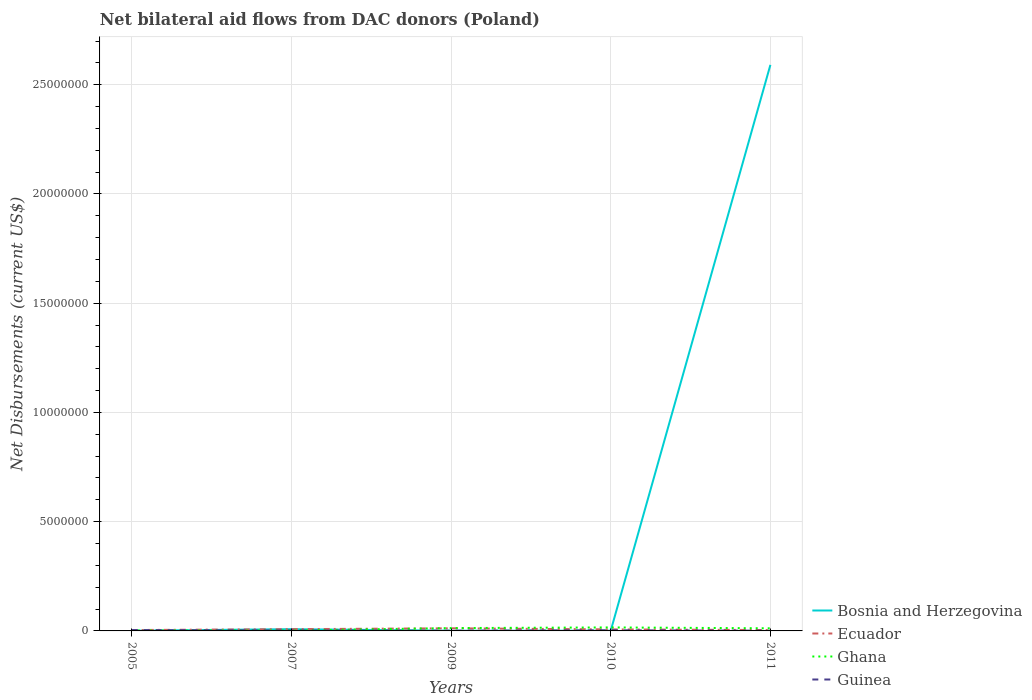Is the number of lines equal to the number of legend labels?
Your response must be concise. Yes. Across all years, what is the maximum net bilateral aid flows in Ecuador?
Offer a very short reply. 4.00e+04. What is the total net bilateral aid flows in Bosnia and Herzegovina in the graph?
Ensure brevity in your answer.  -2.59e+07. Does the graph contain any zero values?
Your answer should be compact. No. Does the graph contain grids?
Your answer should be compact. Yes. How are the legend labels stacked?
Ensure brevity in your answer.  Vertical. What is the title of the graph?
Your response must be concise. Net bilateral aid flows from DAC donors (Poland). What is the label or title of the Y-axis?
Your answer should be compact. Net Disbursements (current US$). What is the Net Disbursements (current US$) in Ecuador in 2005?
Your answer should be very brief. 4.00e+04. What is the Net Disbursements (current US$) of Ghana in 2009?
Offer a terse response. 1.30e+05. What is the Net Disbursements (current US$) of Guinea in 2009?
Provide a succinct answer. 10000. What is the Net Disbursements (current US$) of Bosnia and Herzegovina in 2010?
Provide a short and direct response. 10000. What is the Net Disbursements (current US$) of Ecuador in 2010?
Provide a short and direct response. 7.00e+04. What is the Net Disbursements (current US$) in Guinea in 2010?
Ensure brevity in your answer.  3.00e+04. What is the Net Disbursements (current US$) of Bosnia and Herzegovina in 2011?
Provide a short and direct response. 2.59e+07. What is the Net Disbursements (current US$) of Ecuador in 2011?
Your response must be concise. 4.00e+04. What is the Net Disbursements (current US$) in Ghana in 2011?
Make the answer very short. 1.20e+05. What is the Net Disbursements (current US$) of Guinea in 2011?
Offer a very short reply. 10000. Across all years, what is the maximum Net Disbursements (current US$) in Bosnia and Herzegovina?
Your response must be concise. 2.59e+07. Across all years, what is the minimum Net Disbursements (current US$) of Ghana?
Make the answer very short. 2.00e+04. What is the total Net Disbursements (current US$) of Bosnia and Herzegovina in the graph?
Your answer should be compact. 2.60e+07. What is the total Net Disbursements (current US$) of Ecuador in the graph?
Offer a very short reply. 3.50e+05. What is the difference between the Net Disbursements (current US$) of Bosnia and Herzegovina in 2005 and that in 2007?
Offer a very short reply. -7.00e+04. What is the difference between the Net Disbursements (current US$) of Ghana in 2005 and that in 2007?
Your response must be concise. 0. What is the difference between the Net Disbursements (current US$) of Ghana in 2005 and that in 2009?
Ensure brevity in your answer.  -1.10e+05. What is the difference between the Net Disbursements (current US$) in Ghana in 2005 and that in 2010?
Provide a succinct answer. -1.40e+05. What is the difference between the Net Disbursements (current US$) in Bosnia and Herzegovina in 2005 and that in 2011?
Provide a succinct answer. -2.59e+07. What is the difference between the Net Disbursements (current US$) of Ecuador in 2005 and that in 2011?
Your answer should be compact. 0. What is the difference between the Net Disbursements (current US$) in Ghana in 2005 and that in 2011?
Offer a terse response. -1.00e+05. What is the difference between the Net Disbursements (current US$) of Guinea in 2005 and that in 2011?
Your response must be concise. 3.00e+04. What is the difference between the Net Disbursements (current US$) of Bosnia and Herzegovina in 2007 and that in 2009?
Your answer should be very brief. 7.00e+04. What is the difference between the Net Disbursements (current US$) in Ghana in 2007 and that in 2009?
Give a very brief answer. -1.10e+05. What is the difference between the Net Disbursements (current US$) in Bosnia and Herzegovina in 2007 and that in 2010?
Offer a terse response. 7.00e+04. What is the difference between the Net Disbursements (current US$) of Ecuador in 2007 and that in 2010?
Make the answer very short. 10000. What is the difference between the Net Disbursements (current US$) of Ghana in 2007 and that in 2010?
Your response must be concise. -1.40e+05. What is the difference between the Net Disbursements (current US$) of Bosnia and Herzegovina in 2007 and that in 2011?
Give a very brief answer. -2.58e+07. What is the difference between the Net Disbursements (current US$) in Ghana in 2007 and that in 2011?
Keep it short and to the point. -1.00e+05. What is the difference between the Net Disbursements (current US$) of Bosnia and Herzegovina in 2009 and that in 2010?
Your answer should be compact. 0. What is the difference between the Net Disbursements (current US$) in Bosnia and Herzegovina in 2009 and that in 2011?
Offer a very short reply. -2.59e+07. What is the difference between the Net Disbursements (current US$) in Guinea in 2009 and that in 2011?
Your response must be concise. 0. What is the difference between the Net Disbursements (current US$) of Bosnia and Herzegovina in 2010 and that in 2011?
Give a very brief answer. -2.59e+07. What is the difference between the Net Disbursements (current US$) of Ecuador in 2010 and that in 2011?
Offer a terse response. 3.00e+04. What is the difference between the Net Disbursements (current US$) in Ghana in 2010 and that in 2011?
Your answer should be compact. 4.00e+04. What is the difference between the Net Disbursements (current US$) of Bosnia and Herzegovina in 2005 and the Net Disbursements (current US$) of Ecuador in 2007?
Give a very brief answer. -7.00e+04. What is the difference between the Net Disbursements (current US$) of Bosnia and Herzegovina in 2005 and the Net Disbursements (current US$) of Guinea in 2007?
Keep it short and to the point. -10000. What is the difference between the Net Disbursements (current US$) of Ecuador in 2005 and the Net Disbursements (current US$) of Ghana in 2007?
Give a very brief answer. 2.00e+04. What is the difference between the Net Disbursements (current US$) in Bosnia and Herzegovina in 2005 and the Net Disbursements (current US$) in Ecuador in 2009?
Provide a short and direct response. -1.10e+05. What is the difference between the Net Disbursements (current US$) of Ecuador in 2005 and the Net Disbursements (current US$) of Ghana in 2009?
Ensure brevity in your answer.  -9.00e+04. What is the difference between the Net Disbursements (current US$) of Ecuador in 2005 and the Net Disbursements (current US$) of Guinea in 2009?
Make the answer very short. 3.00e+04. What is the difference between the Net Disbursements (current US$) in Ghana in 2005 and the Net Disbursements (current US$) in Guinea in 2009?
Ensure brevity in your answer.  10000. What is the difference between the Net Disbursements (current US$) in Ecuador in 2005 and the Net Disbursements (current US$) in Guinea in 2010?
Give a very brief answer. 10000. What is the difference between the Net Disbursements (current US$) in Ghana in 2005 and the Net Disbursements (current US$) in Guinea in 2010?
Offer a very short reply. -10000. What is the difference between the Net Disbursements (current US$) in Bosnia and Herzegovina in 2005 and the Net Disbursements (current US$) in Ecuador in 2011?
Give a very brief answer. -3.00e+04. What is the difference between the Net Disbursements (current US$) in Bosnia and Herzegovina in 2005 and the Net Disbursements (current US$) in Ghana in 2011?
Your response must be concise. -1.10e+05. What is the difference between the Net Disbursements (current US$) of Bosnia and Herzegovina in 2005 and the Net Disbursements (current US$) of Guinea in 2011?
Your response must be concise. 0. What is the difference between the Net Disbursements (current US$) of Bosnia and Herzegovina in 2007 and the Net Disbursements (current US$) of Ecuador in 2009?
Your response must be concise. -4.00e+04. What is the difference between the Net Disbursements (current US$) in Bosnia and Herzegovina in 2007 and the Net Disbursements (current US$) in Ghana in 2009?
Keep it short and to the point. -5.00e+04. What is the difference between the Net Disbursements (current US$) in Bosnia and Herzegovina in 2007 and the Net Disbursements (current US$) in Guinea in 2009?
Ensure brevity in your answer.  7.00e+04. What is the difference between the Net Disbursements (current US$) in Bosnia and Herzegovina in 2007 and the Net Disbursements (current US$) in Ghana in 2010?
Offer a terse response. -8.00e+04. What is the difference between the Net Disbursements (current US$) in Ecuador in 2007 and the Net Disbursements (current US$) in Ghana in 2010?
Offer a very short reply. -8.00e+04. What is the difference between the Net Disbursements (current US$) in Ecuador in 2007 and the Net Disbursements (current US$) in Guinea in 2010?
Your answer should be compact. 5.00e+04. What is the difference between the Net Disbursements (current US$) of Ghana in 2007 and the Net Disbursements (current US$) of Guinea in 2010?
Make the answer very short. -10000. What is the difference between the Net Disbursements (current US$) in Ecuador in 2007 and the Net Disbursements (current US$) in Ghana in 2011?
Make the answer very short. -4.00e+04. What is the difference between the Net Disbursements (current US$) of Bosnia and Herzegovina in 2009 and the Net Disbursements (current US$) of Ghana in 2010?
Make the answer very short. -1.50e+05. What is the difference between the Net Disbursements (current US$) of Ghana in 2009 and the Net Disbursements (current US$) of Guinea in 2010?
Your answer should be very brief. 1.00e+05. What is the difference between the Net Disbursements (current US$) in Bosnia and Herzegovina in 2009 and the Net Disbursements (current US$) in Ecuador in 2011?
Provide a short and direct response. -3.00e+04. What is the difference between the Net Disbursements (current US$) in Bosnia and Herzegovina in 2009 and the Net Disbursements (current US$) in Ghana in 2011?
Give a very brief answer. -1.10e+05. What is the difference between the Net Disbursements (current US$) in Bosnia and Herzegovina in 2009 and the Net Disbursements (current US$) in Guinea in 2011?
Ensure brevity in your answer.  0. What is the difference between the Net Disbursements (current US$) of Ecuador in 2009 and the Net Disbursements (current US$) of Ghana in 2011?
Your answer should be very brief. 0. What is the difference between the Net Disbursements (current US$) in Bosnia and Herzegovina in 2010 and the Net Disbursements (current US$) in Ecuador in 2011?
Keep it short and to the point. -3.00e+04. What is the difference between the Net Disbursements (current US$) in Ghana in 2010 and the Net Disbursements (current US$) in Guinea in 2011?
Your answer should be compact. 1.50e+05. What is the average Net Disbursements (current US$) of Bosnia and Herzegovina per year?
Offer a terse response. 5.20e+06. What is the average Net Disbursements (current US$) of Ecuador per year?
Keep it short and to the point. 7.00e+04. What is the average Net Disbursements (current US$) of Ghana per year?
Give a very brief answer. 9.00e+04. What is the average Net Disbursements (current US$) of Guinea per year?
Make the answer very short. 2.20e+04. In the year 2005, what is the difference between the Net Disbursements (current US$) of Bosnia and Herzegovina and Net Disbursements (current US$) of Ghana?
Provide a succinct answer. -10000. In the year 2005, what is the difference between the Net Disbursements (current US$) of Bosnia and Herzegovina and Net Disbursements (current US$) of Guinea?
Provide a short and direct response. -3.00e+04. In the year 2005, what is the difference between the Net Disbursements (current US$) of Ecuador and Net Disbursements (current US$) of Ghana?
Offer a very short reply. 2.00e+04. In the year 2005, what is the difference between the Net Disbursements (current US$) of Ecuador and Net Disbursements (current US$) of Guinea?
Give a very brief answer. 0. In the year 2005, what is the difference between the Net Disbursements (current US$) in Ghana and Net Disbursements (current US$) in Guinea?
Keep it short and to the point. -2.00e+04. In the year 2007, what is the difference between the Net Disbursements (current US$) of Bosnia and Herzegovina and Net Disbursements (current US$) of Ghana?
Your response must be concise. 6.00e+04. In the year 2007, what is the difference between the Net Disbursements (current US$) of Ecuador and Net Disbursements (current US$) of Ghana?
Offer a very short reply. 6.00e+04. In the year 2007, what is the difference between the Net Disbursements (current US$) of Ecuador and Net Disbursements (current US$) of Guinea?
Your response must be concise. 6.00e+04. In the year 2007, what is the difference between the Net Disbursements (current US$) of Ghana and Net Disbursements (current US$) of Guinea?
Keep it short and to the point. 0. In the year 2009, what is the difference between the Net Disbursements (current US$) in Bosnia and Herzegovina and Net Disbursements (current US$) in Ecuador?
Provide a short and direct response. -1.10e+05. In the year 2009, what is the difference between the Net Disbursements (current US$) in Bosnia and Herzegovina and Net Disbursements (current US$) in Guinea?
Give a very brief answer. 0. In the year 2009, what is the difference between the Net Disbursements (current US$) of Ecuador and Net Disbursements (current US$) of Guinea?
Make the answer very short. 1.10e+05. In the year 2010, what is the difference between the Net Disbursements (current US$) in Bosnia and Herzegovina and Net Disbursements (current US$) in Ecuador?
Ensure brevity in your answer.  -6.00e+04. In the year 2010, what is the difference between the Net Disbursements (current US$) in Ghana and Net Disbursements (current US$) in Guinea?
Make the answer very short. 1.30e+05. In the year 2011, what is the difference between the Net Disbursements (current US$) of Bosnia and Herzegovina and Net Disbursements (current US$) of Ecuador?
Offer a very short reply. 2.59e+07. In the year 2011, what is the difference between the Net Disbursements (current US$) of Bosnia and Herzegovina and Net Disbursements (current US$) of Ghana?
Offer a very short reply. 2.58e+07. In the year 2011, what is the difference between the Net Disbursements (current US$) in Bosnia and Herzegovina and Net Disbursements (current US$) in Guinea?
Your answer should be very brief. 2.59e+07. In the year 2011, what is the difference between the Net Disbursements (current US$) in Ecuador and Net Disbursements (current US$) in Ghana?
Make the answer very short. -8.00e+04. In the year 2011, what is the difference between the Net Disbursements (current US$) in Ecuador and Net Disbursements (current US$) in Guinea?
Your answer should be compact. 3.00e+04. In the year 2011, what is the difference between the Net Disbursements (current US$) in Ghana and Net Disbursements (current US$) in Guinea?
Offer a terse response. 1.10e+05. What is the ratio of the Net Disbursements (current US$) in Ecuador in 2005 to that in 2007?
Offer a very short reply. 0.5. What is the ratio of the Net Disbursements (current US$) of Ghana in 2005 to that in 2007?
Ensure brevity in your answer.  1. What is the ratio of the Net Disbursements (current US$) of Guinea in 2005 to that in 2007?
Provide a succinct answer. 2. What is the ratio of the Net Disbursements (current US$) of Bosnia and Herzegovina in 2005 to that in 2009?
Give a very brief answer. 1. What is the ratio of the Net Disbursements (current US$) in Ecuador in 2005 to that in 2009?
Your answer should be compact. 0.33. What is the ratio of the Net Disbursements (current US$) of Ghana in 2005 to that in 2009?
Offer a terse response. 0.15. What is the ratio of the Net Disbursements (current US$) in Guinea in 2005 to that in 2009?
Make the answer very short. 4. What is the ratio of the Net Disbursements (current US$) in Bosnia and Herzegovina in 2005 to that in 2010?
Give a very brief answer. 1. What is the ratio of the Net Disbursements (current US$) in Ecuador in 2005 to that in 2010?
Offer a very short reply. 0.57. What is the ratio of the Net Disbursements (current US$) of Guinea in 2005 to that in 2010?
Provide a succinct answer. 1.33. What is the ratio of the Net Disbursements (current US$) of Bosnia and Herzegovina in 2005 to that in 2011?
Keep it short and to the point. 0. What is the ratio of the Net Disbursements (current US$) of Ecuador in 2005 to that in 2011?
Give a very brief answer. 1. What is the ratio of the Net Disbursements (current US$) in Ghana in 2005 to that in 2011?
Keep it short and to the point. 0.17. What is the ratio of the Net Disbursements (current US$) in Ecuador in 2007 to that in 2009?
Keep it short and to the point. 0.67. What is the ratio of the Net Disbursements (current US$) of Ghana in 2007 to that in 2009?
Give a very brief answer. 0.15. What is the ratio of the Net Disbursements (current US$) of Guinea in 2007 to that in 2009?
Provide a succinct answer. 2. What is the ratio of the Net Disbursements (current US$) of Bosnia and Herzegovina in 2007 to that in 2011?
Provide a succinct answer. 0. What is the ratio of the Net Disbursements (current US$) of Bosnia and Herzegovina in 2009 to that in 2010?
Offer a terse response. 1. What is the ratio of the Net Disbursements (current US$) in Ecuador in 2009 to that in 2010?
Offer a very short reply. 1.71. What is the ratio of the Net Disbursements (current US$) in Ghana in 2009 to that in 2010?
Offer a very short reply. 0.81. What is the ratio of the Net Disbursements (current US$) in Guinea in 2009 to that in 2010?
Ensure brevity in your answer.  0.33. What is the ratio of the Net Disbursements (current US$) in Ecuador in 2009 to that in 2011?
Your response must be concise. 3. What is the ratio of the Net Disbursements (current US$) in Ghana in 2010 to that in 2011?
Provide a succinct answer. 1.33. What is the ratio of the Net Disbursements (current US$) in Guinea in 2010 to that in 2011?
Offer a terse response. 3. What is the difference between the highest and the second highest Net Disbursements (current US$) in Bosnia and Herzegovina?
Provide a succinct answer. 2.58e+07. What is the difference between the highest and the second highest Net Disbursements (current US$) of Ecuador?
Give a very brief answer. 4.00e+04. What is the difference between the highest and the second highest Net Disbursements (current US$) of Ghana?
Keep it short and to the point. 3.00e+04. What is the difference between the highest and the lowest Net Disbursements (current US$) in Bosnia and Herzegovina?
Give a very brief answer. 2.59e+07. What is the difference between the highest and the lowest Net Disbursements (current US$) in Ghana?
Your answer should be compact. 1.40e+05. What is the difference between the highest and the lowest Net Disbursements (current US$) in Guinea?
Your answer should be very brief. 3.00e+04. 